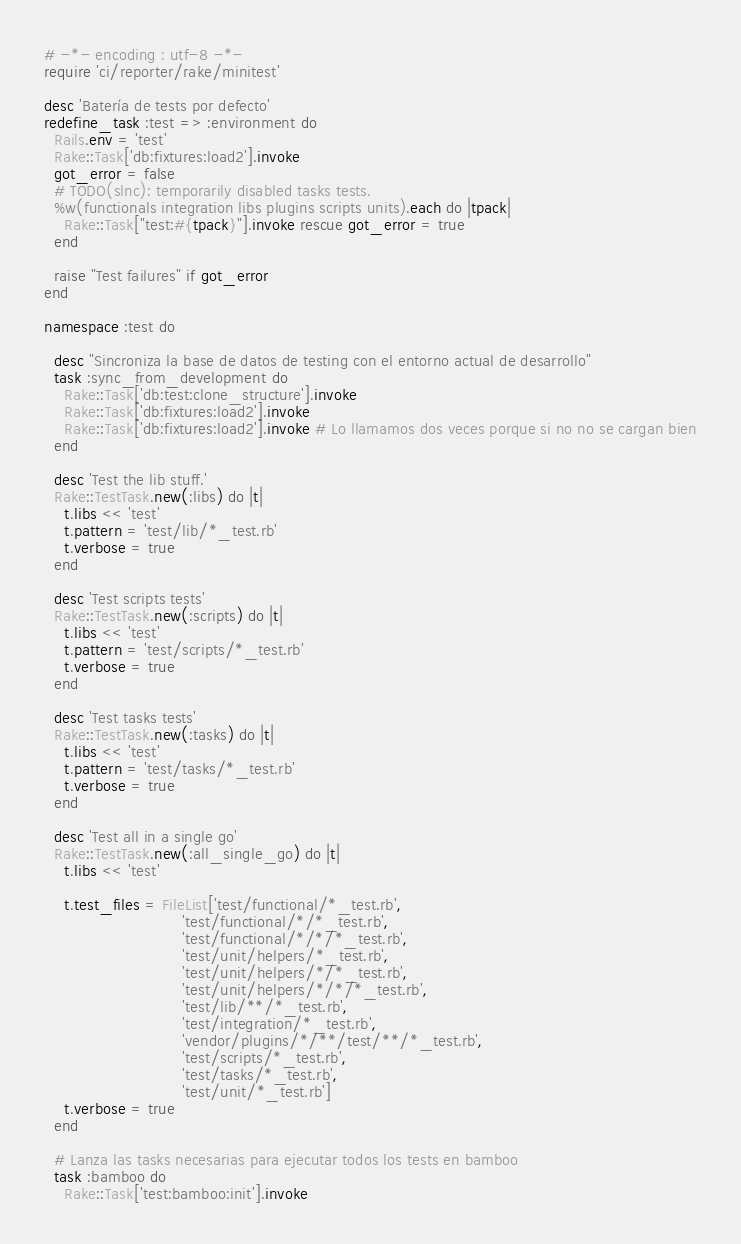<code> <loc_0><loc_0><loc_500><loc_500><_Ruby_># -*- encoding : utf-8 -*-
require 'ci/reporter/rake/minitest'

desc 'Batería de tests por defecto'
redefine_task :test => :environment do
  Rails.env = 'test'
  Rake::Task['db:fixtures:load2'].invoke
  got_error = false
  # TODO(slnc): temporarily disabled tasks tests.
  %w(functionals integration libs plugins scripts units).each do |tpack|
    Rake::Task["test:#{tpack}"].invoke rescue got_error = true
  end

  raise "Test failures" if got_error
end

namespace :test do

  desc "Sincroniza la base de datos de testing con el entorno actual de desarrollo"
  task :sync_from_development do
    Rake::Task['db:test:clone_structure'].invoke
    Rake::Task['db:fixtures:load2'].invoke
    Rake::Task['db:fixtures:load2'].invoke # Lo llamamos dos veces porque si no no se cargan bien
  end

  desc 'Test the lib stuff.'
  Rake::TestTask.new(:libs) do |t|
    t.libs << 'test'
    t.pattern = 'test/lib/*_test.rb'
    t.verbose = true
  end

  desc 'Test scripts tests'
  Rake::TestTask.new(:scripts) do |t|
    t.libs << 'test'
    t.pattern = 'test/scripts/*_test.rb'
    t.verbose = true
  end

  desc 'Test tasks tests'
  Rake::TestTask.new(:tasks) do |t|
    t.libs << 'test'
    t.pattern = 'test/tasks/*_test.rb'
    t.verbose = true
  end

  desc 'Test all in a single go'
  Rake::TestTask.new(:all_single_go) do |t|
    t.libs << 'test'

    t.test_files = FileList['test/functional/*_test.rb',
                            'test/functional/*/*_test.rb',
                            'test/functional/*/*/*_test.rb',
                            'test/unit/helpers/*_test.rb',
                            'test/unit/helpers/*/*_test.rb',
                            'test/unit/helpers/*/*/*_test.rb',
                            'test/lib/**/*_test.rb',
                            'test/integration/*_test.rb',
                            'vendor/plugins/*/**/test/**/*_test.rb',
                            'test/scripts/*_test.rb',
                            'test/tasks/*_test.rb',
                            'test/unit/*_test.rb']
    t.verbose = true
  end

  # Lanza las tasks necesarias para ejecutar todos los tests en bamboo
  task :bamboo do
    Rake::Task['test:bamboo:init'].invoke</code> 